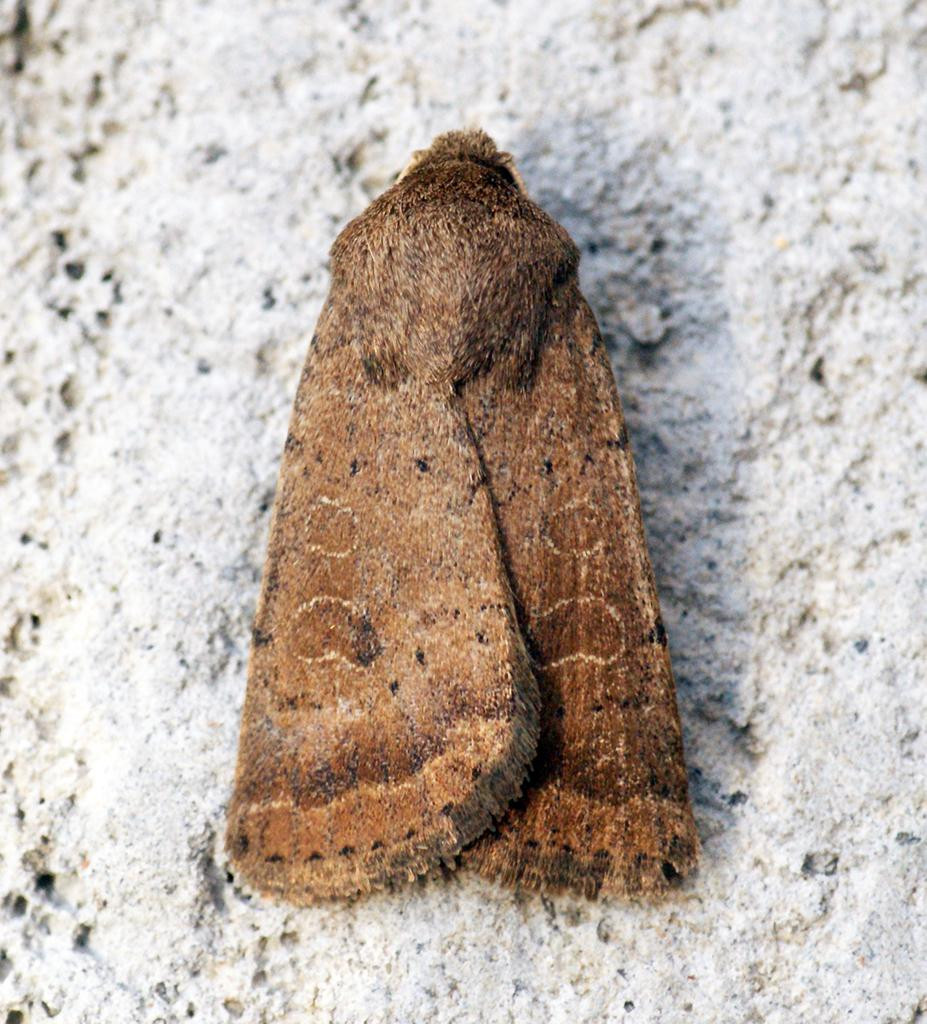What is present on the white surface in the image? There is an insect on the white surface in the image. What colors can be seen on the insect? The insect has brown and black colors. What type of list is visible on the white surface in the image? There is no list present on the white surface in the image; it only features an insect. How does the ant interact with the insect in the image? There is no ant present in the image, so it cannot interact with the insect. 